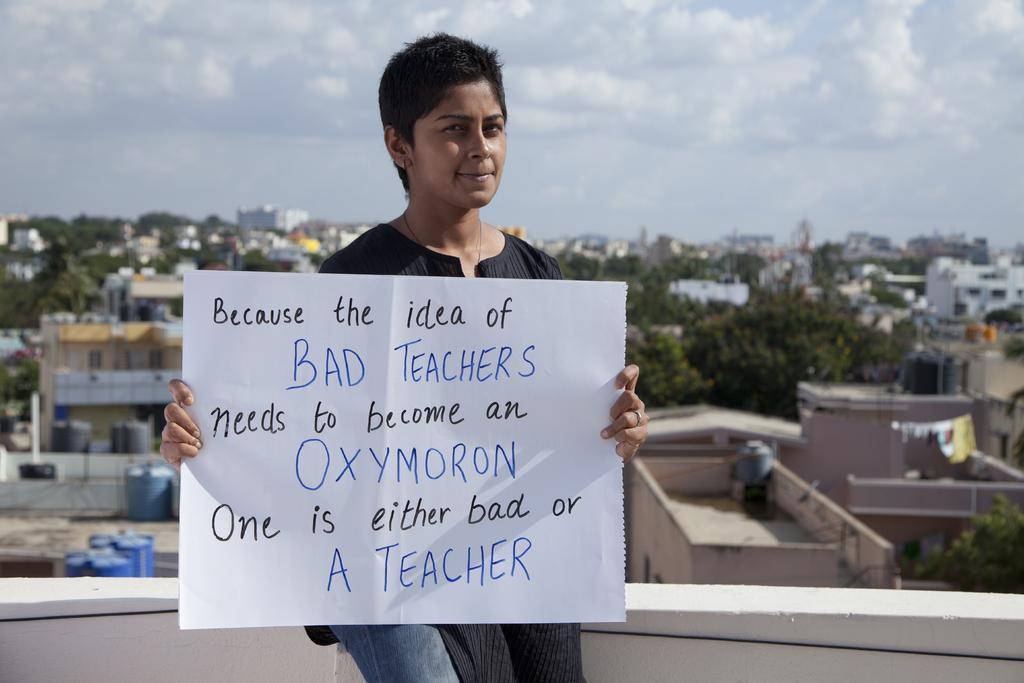How would you summarize this image in a sentence or two? In the image I can see a person who is holding the note on which there is something written and behind I can see the view of a place where we have some buildings, houses and some trees. 